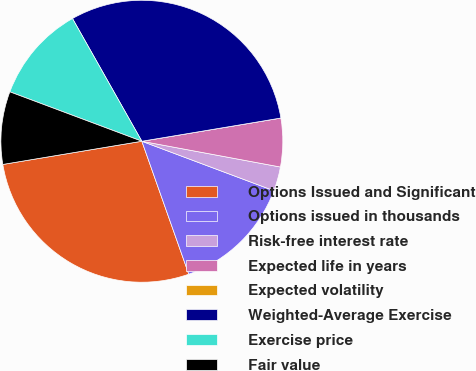Convert chart to OTSL. <chart><loc_0><loc_0><loc_500><loc_500><pie_chart><fcel>Options Issued and Significant<fcel>Options issued in thousands<fcel>Risk-free interest rate<fcel>Expected life in years<fcel>Expected volatility<fcel>Weighted-Average Exercise<fcel>Exercise price<fcel>Fair value<nl><fcel>27.77%<fcel>13.89%<fcel>2.78%<fcel>5.56%<fcel>0.0%<fcel>30.55%<fcel>11.11%<fcel>8.33%<nl></chart> 